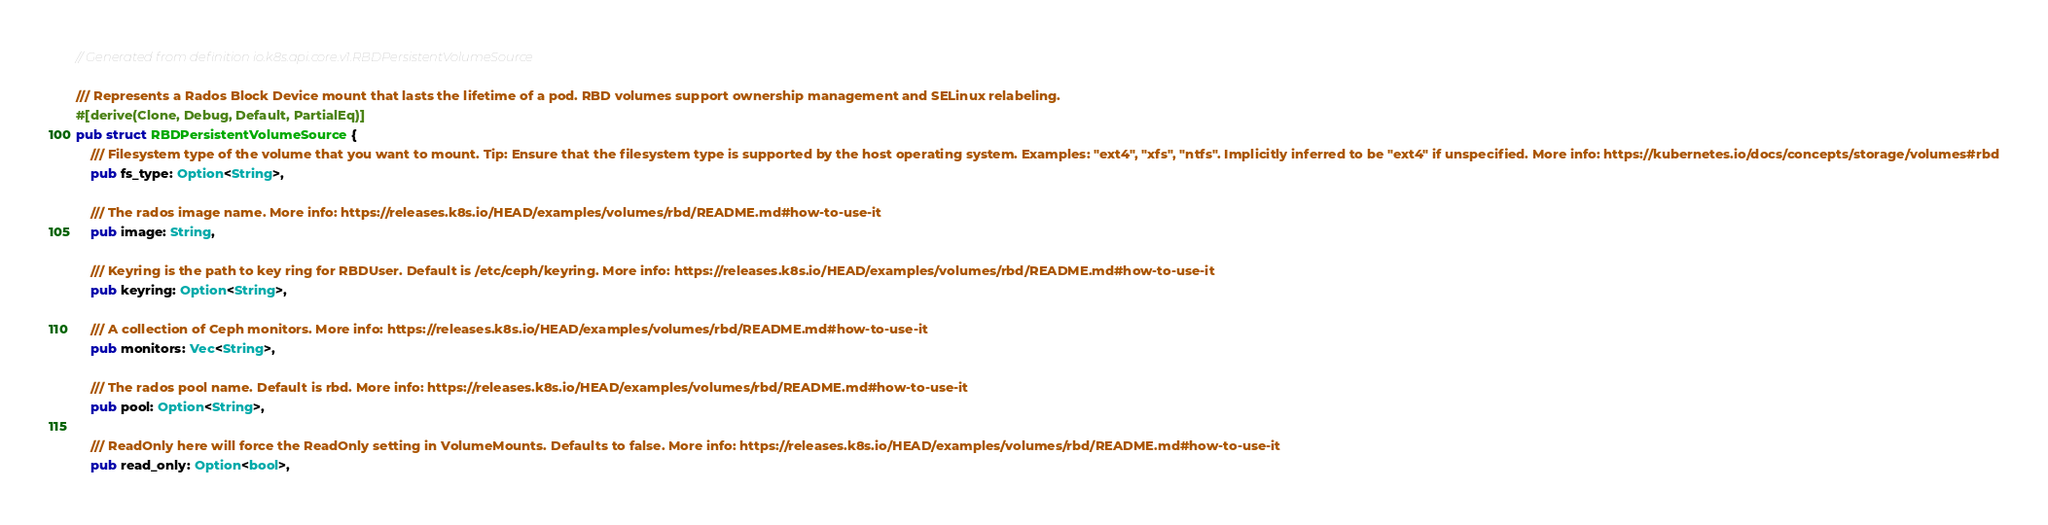<code> <loc_0><loc_0><loc_500><loc_500><_Rust_>// Generated from definition io.k8s.api.core.v1.RBDPersistentVolumeSource

/// Represents a Rados Block Device mount that lasts the lifetime of a pod. RBD volumes support ownership management and SELinux relabeling.
#[derive(Clone, Debug, Default, PartialEq)]
pub struct RBDPersistentVolumeSource {
    /// Filesystem type of the volume that you want to mount. Tip: Ensure that the filesystem type is supported by the host operating system. Examples: "ext4", "xfs", "ntfs". Implicitly inferred to be "ext4" if unspecified. More info: https://kubernetes.io/docs/concepts/storage/volumes#rbd
    pub fs_type: Option<String>,

    /// The rados image name. More info: https://releases.k8s.io/HEAD/examples/volumes/rbd/README.md#how-to-use-it
    pub image: String,

    /// Keyring is the path to key ring for RBDUser. Default is /etc/ceph/keyring. More info: https://releases.k8s.io/HEAD/examples/volumes/rbd/README.md#how-to-use-it
    pub keyring: Option<String>,

    /// A collection of Ceph monitors. More info: https://releases.k8s.io/HEAD/examples/volumes/rbd/README.md#how-to-use-it
    pub monitors: Vec<String>,

    /// The rados pool name. Default is rbd. More info: https://releases.k8s.io/HEAD/examples/volumes/rbd/README.md#how-to-use-it
    pub pool: Option<String>,

    /// ReadOnly here will force the ReadOnly setting in VolumeMounts. Defaults to false. More info: https://releases.k8s.io/HEAD/examples/volumes/rbd/README.md#how-to-use-it
    pub read_only: Option<bool>,
</code> 